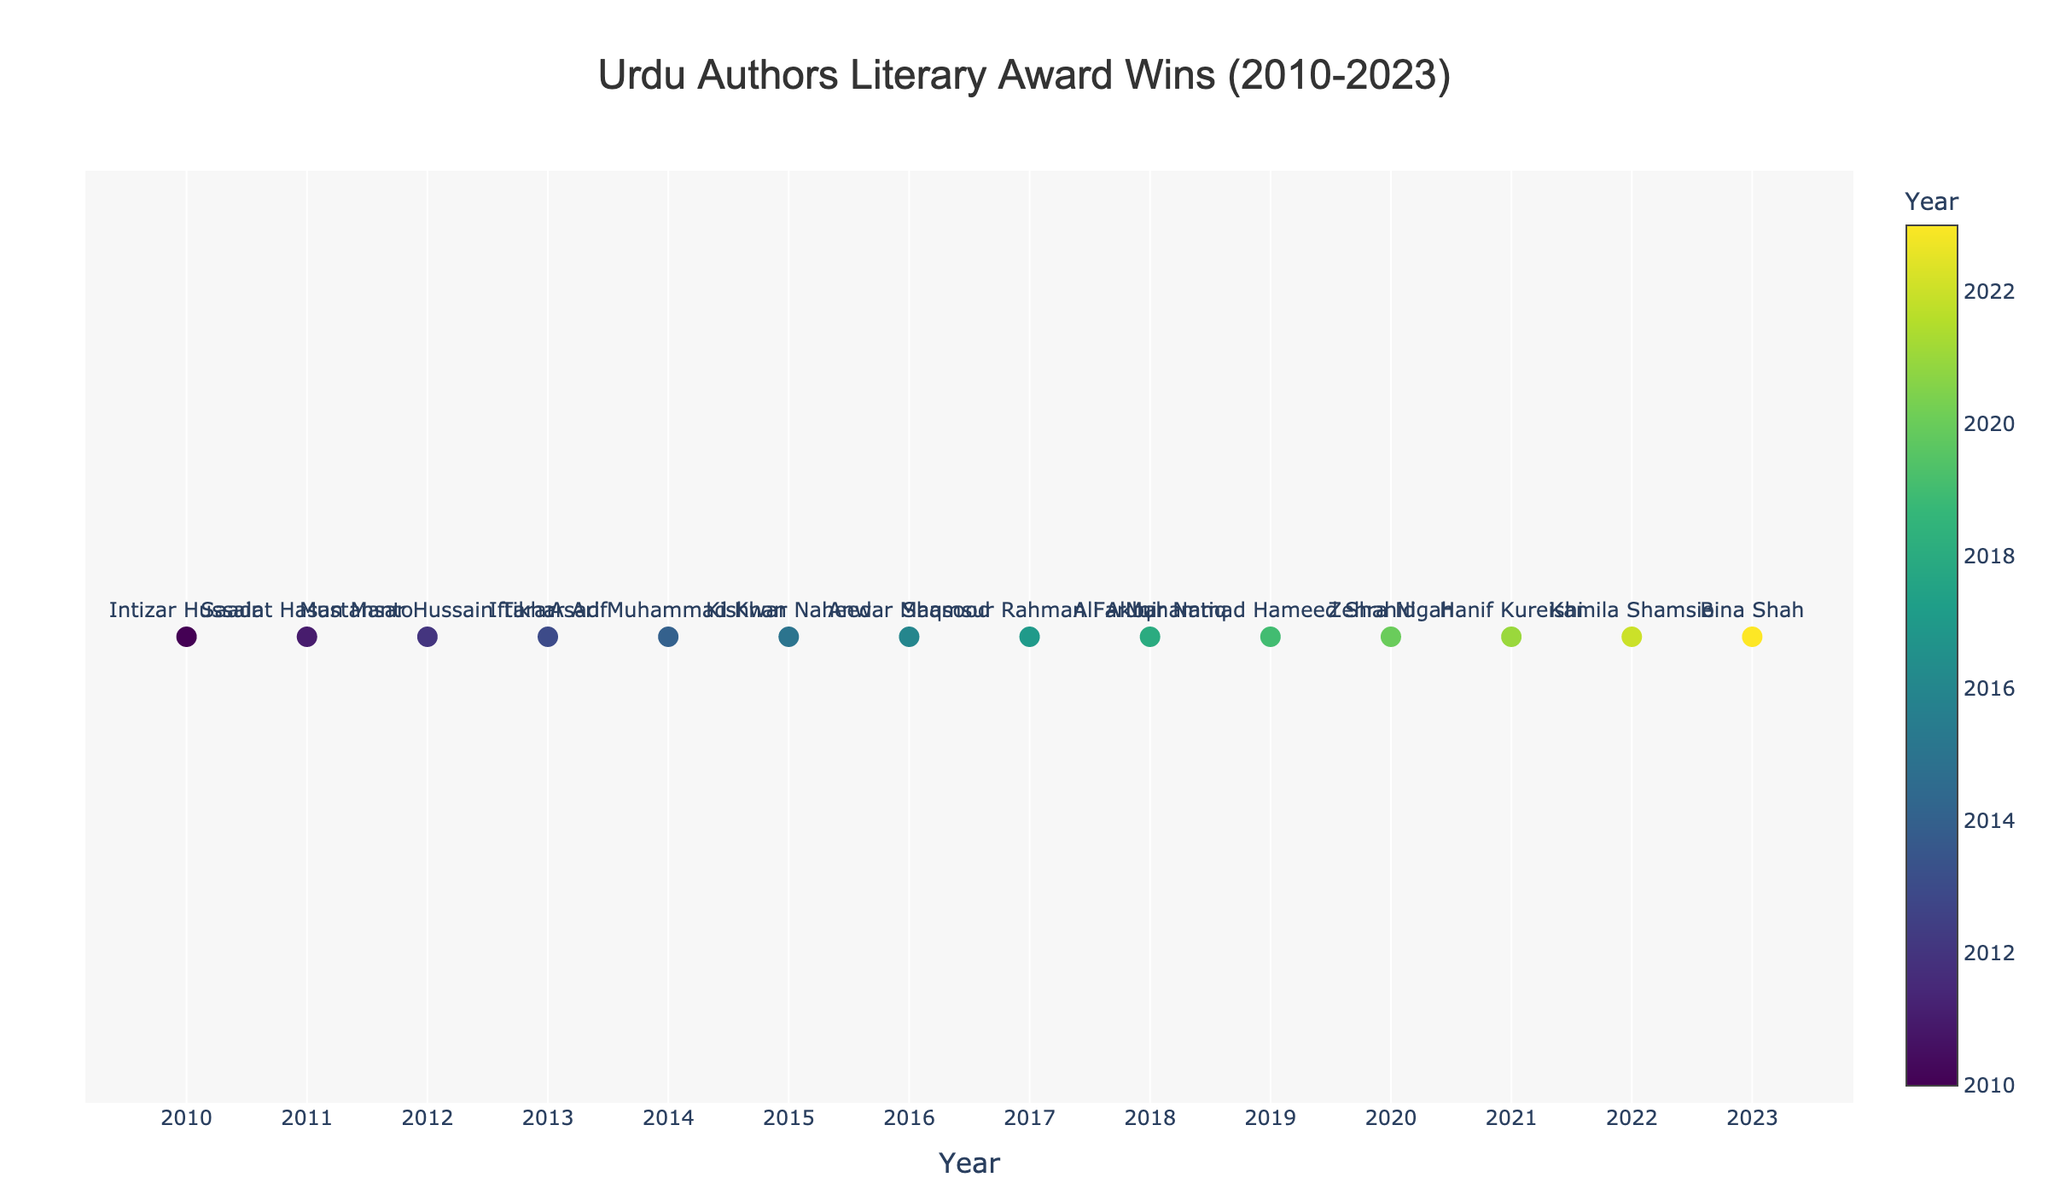How many total literary awards were won by Urdu authors between 2010 and 2023? Count all the data points shown in the plot. Each data point represents a single award win. There are 14 data points.
Answer: 14 What is the most recent year shown on the plot? Look at the x-axis of the time series to find the maximum value indicating the most recent year. It is 2023.
Answer: 2023 Which author won an award in 2011? Identify the marker labeled with the year 2011 and check the text associated with it. The text indicates the author Saadat Hasan Manto.
Answer: Saadat Hasan Manto Which authors won awards in consecutive years? Identify authors from adjacent data points labeled with consecutive years. Authors who won awards consecutively: Muhammad Hameed Shahid (2019), Zehra Nigah (2020).
Answer: Muhammad Hameed Shahid, Zehra Nigah How many authors named in the plot won awards after 2015? Count the data points from 2016 to 2023 and identify the authors' names associated with those points. There are 8 authors.
Answer: 8 Which award has the highest diversity in recipients from different years? Check the hovertext associated with each year and count how often each award appears with different authors. Each award is unique to its recipient, so none has a higher diversity.
Answer: None Did any author win an award more than once? Identify if any author name appears more than once in the labels of the plot. Each label is unique to the author, so no author won more than once.
Answer: No How many awards were won by female authors? Female authors listed are Kishwar Naheed (2015), Zehra Nigah (2020), and Kamila Shamsie (2022), each represented by a single data point. So there are three awards.
Answer: 3 Which award was won by Intizar Hussain? Find the year 2010 on the x-axis and hover over its data point to see the details. The text indicates Intizar Hussain won the Kamala Das South Asian Literary Award.
Answer: Kamala Das South Asian Literary Award Who won the Pushcart Prize and in which year? Locate the data point labeled with the Pushcart Prize from its hovertext. Ali Akbar Natiq won it in 2018.
Answer: Ali Akbar Natiq, 2018 